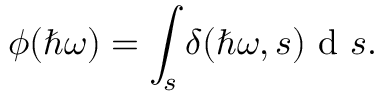Convert formula to latex. <formula><loc_0><loc_0><loc_500><loc_500>\phi ( \hbar { \omega } ) = \int _ { s } \delta ( \hbar { \omega } , s ) d s .</formula> 